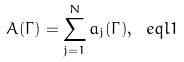<formula> <loc_0><loc_0><loc_500><loc_500>A ( \Gamma ) = \sum _ { j = 1 } ^ { N } a _ { j } ( \Gamma ) , \ e q l { 1 }</formula> 